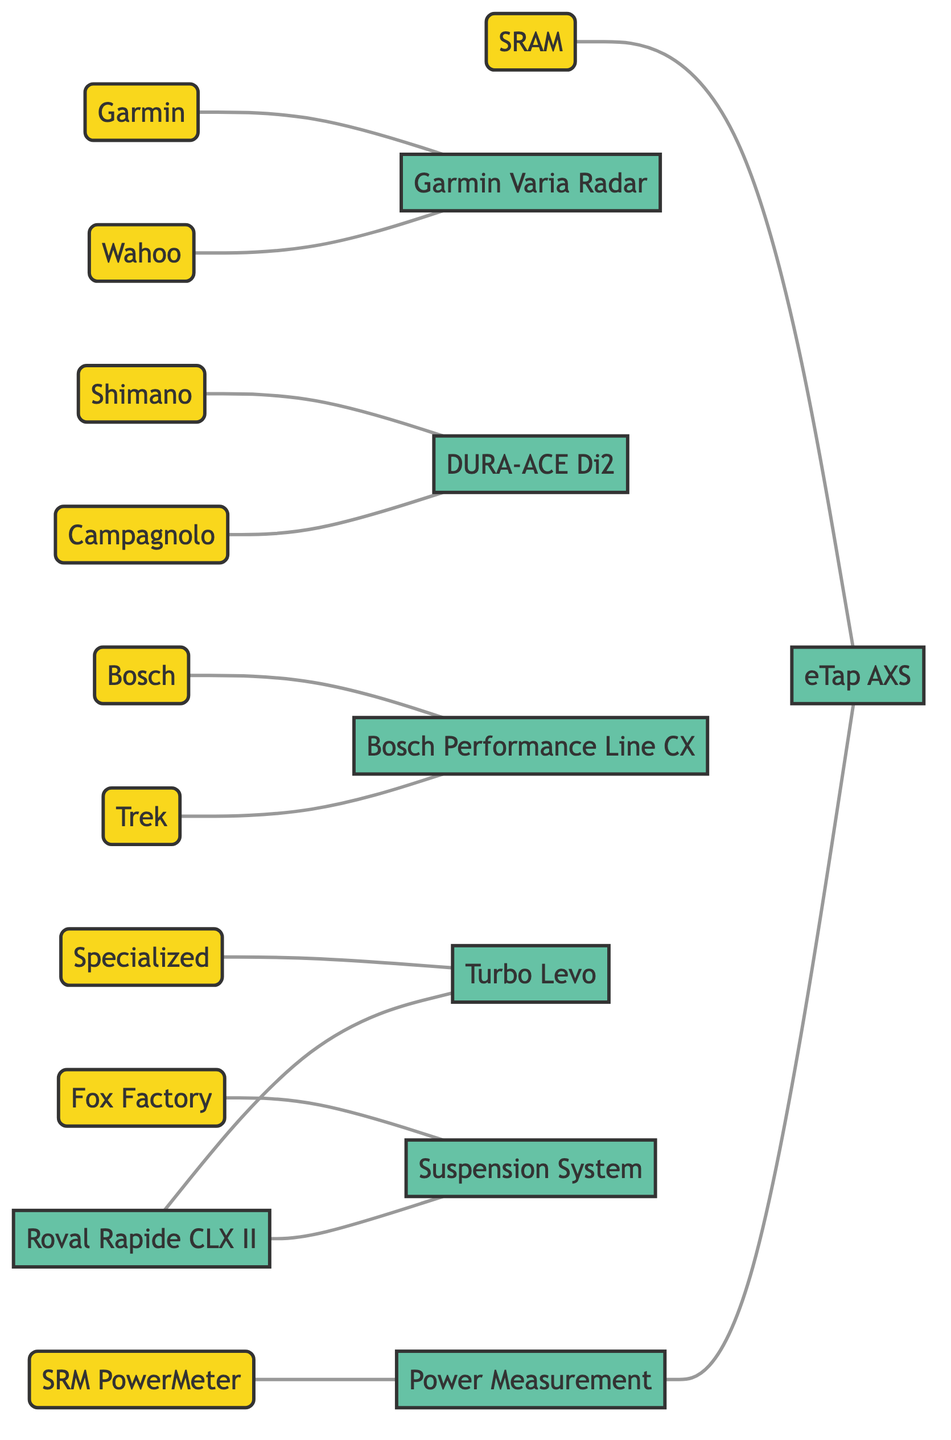What is the total number of companies represented in the diagram? There are ten distinct nodes categorized as companies in the diagram: Shimano, SRAM, Campagnolo, Bosch, Trek, Specialized, Garmin, Wahoo, Fox Factory, and SRM PowerMeter.
Answer: 10 Which technology is directly associated with SRAM? The only technology directly associated with SRAM in the diagram is eTap AXS, as indicated by the direct edge connecting both nodes.
Answer: eTap AXS How many technologies are linked to Roval Rapide CLX II? Roval Rapide CLX II has two direct connections in the diagram, one to Turbo Levo and another to Suspension System, indicating its linkage to these technologies.
Answer: 2 Which company has a connection to the Bosch Performance Line CX technology? The companies that demonstrate a link to Bosch Performance Line CX are Bosch and Trek, as both are directly connected to this technology node in the diagram.
Answer: Bosch, Trek What is the relationship between Power Measurement and eTap AXS? Power Measurement is connected to eTap AXS through a direct edge, signifying a direct relationship where Power Measurement influences or relates to eTap AXS.
Answer: Directly connected How many links are there in total between companies and technologies? By counting all edges in the diagram, which represent the connections between the companies and technologies, the total comes to twelve distinct links, establishing the interactions within the innovation network.
Answer: 12 Which technology is associated with Fox Factory? The technology associated with Fox Factory in the diagram is the Suspension System, as illustrated by the connecting edge between these two nodes.
Answer: Suspension System What type of graph is being used to represent the innovation network? The diagram is an undirected graph, which means that the connections between nodes (companies and technologies) do not have a directional influence; they simply represent relationships.
Answer: Undirected Graph Which company is connected to the most technologies? Roval Rapide CLX II is connected to a total of two technologies: Turbo Levo and Suspension System, while other companies are linked to one technology each, establishing it as the most connected within the graph.
Answer: Roval Rapide CLX II 